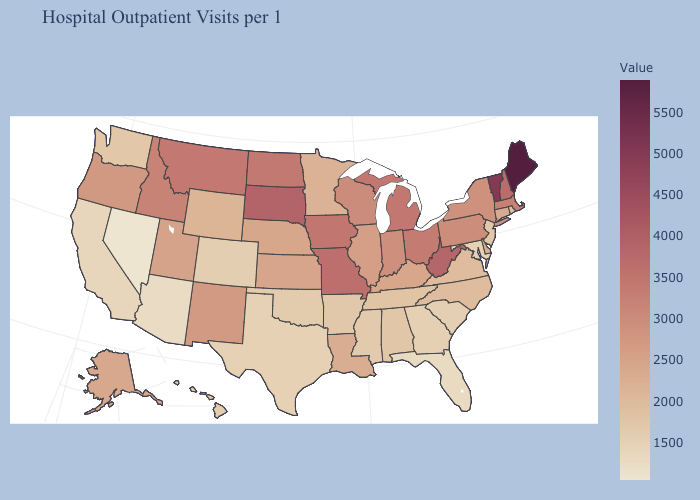Does Hawaii have a higher value than Kentucky?
Write a very short answer. No. Among the states that border Montana , does Wyoming have the lowest value?
Quick response, please. Yes. Among the states that border South Dakota , which have the highest value?
Answer briefly. Iowa. Does Maine have the highest value in the Northeast?
Keep it brief. Yes. 